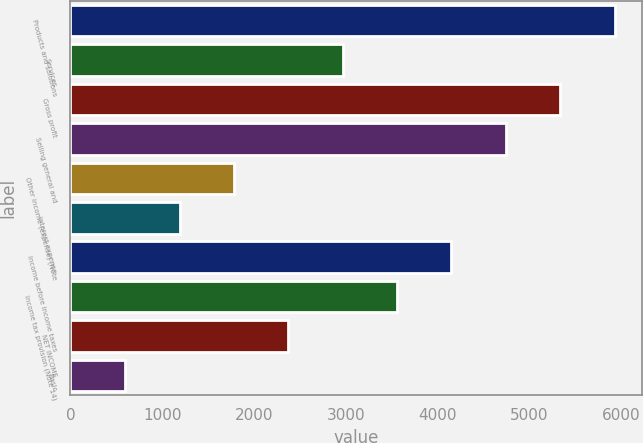Convert chart to OTSL. <chart><loc_0><loc_0><loc_500><loc_500><bar_chart><fcel>Products and solutions<fcel>Services<fcel>Gross profit<fcel>Selling general and<fcel>Other income (expense) (Note<fcel>Interest expense<fcel>Income before income taxes<fcel>Income tax provision (Note 14)<fcel>NET INCOME<fcel>Basic<nl><fcel>5930.51<fcel>2967.36<fcel>5337.88<fcel>4745.25<fcel>1782.1<fcel>1189.47<fcel>4152.62<fcel>3559.99<fcel>2374.73<fcel>596.84<nl></chart> 